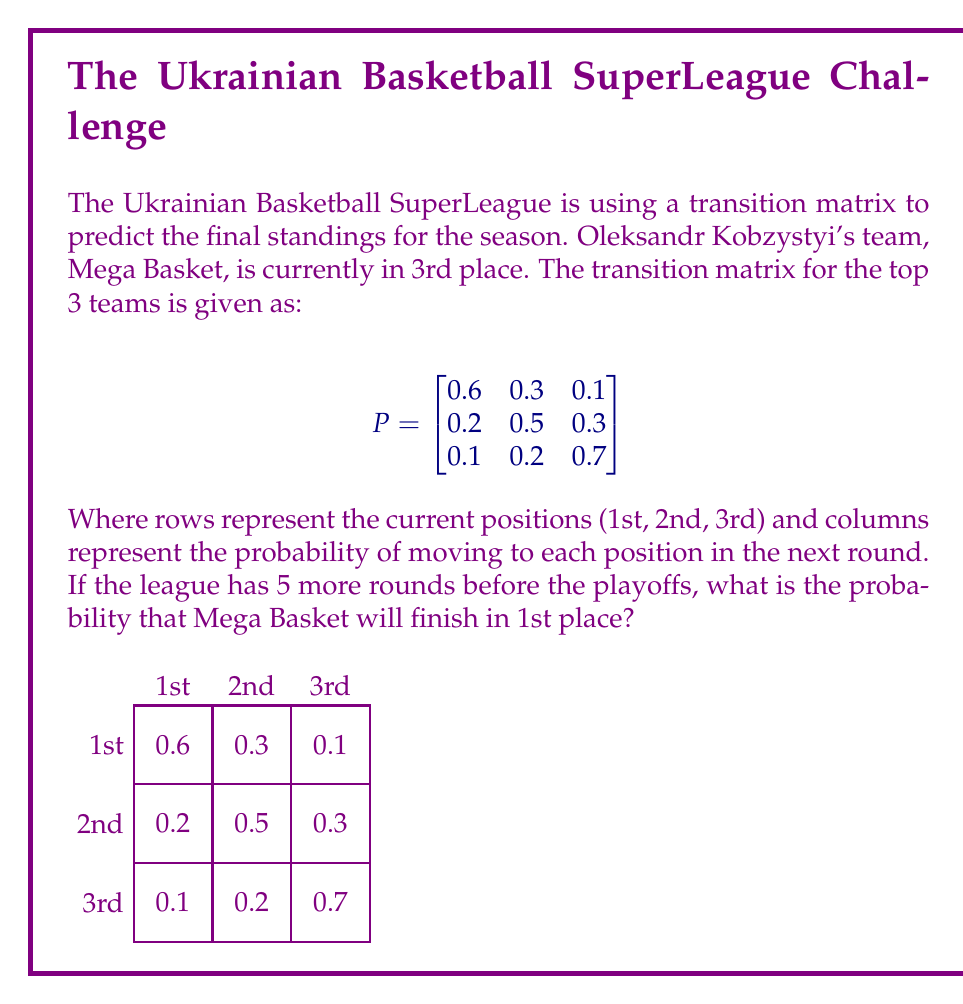Solve this math problem. To solve this problem, we need to use the properties of transition matrices and matrix multiplication. Here's a step-by-step approach:

1) First, we need to calculate the probability distribution after 5 rounds. This can be done by multiplying the transition matrix by itself 5 times:

   $P^5 = P \times P \times P \times P \times P$

2) We can use a calculator or computer to perform this multiplication. The result is:

   $$P^5 \approx \begin{bmatrix}
   0.3432 & 0.2616 & 0.3952 \\
   0.3144 & 0.2568 & 0.4288 \\
   0.2856 & 0.2520 & 0.4624
   \end{bmatrix}$$

3) Mega Basket is currently in 3rd place, so we're interested in the third row of this matrix.

4) The probability of Mega Basket finishing in 1st place after 5 rounds is given by the first element of the third row:

   $P(\text{1st place}) \approx 0.2856$

5) To convert this to a percentage, we multiply by 100:

   $0.2856 \times 100 \approx 28.56\%$

Therefore, the probability that Mega Basket will finish in 1st place after 5 more rounds is approximately 28.56%.
Answer: 28.56% 